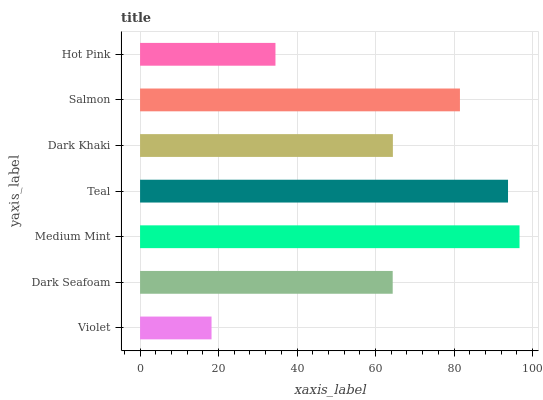Is Violet the minimum?
Answer yes or no. Yes. Is Medium Mint the maximum?
Answer yes or no. Yes. Is Dark Seafoam the minimum?
Answer yes or no. No. Is Dark Seafoam the maximum?
Answer yes or no. No. Is Dark Seafoam greater than Violet?
Answer yes or no. Yes. Is Violet less than Dark Seafoam?
Answer yes or no. Yes. Is Violet greater than Dark Seafoam?
Answer yes or no. No. Is Dark Seafoam less than Violet?
Answer yes or no. No. Is Dark Khaki the high median?
Answer yes or no. Yes. Is Dark Khaki the low median?
Answer yes or no. Yes. Is Teal the high median?
Answer yes or no. No. Is Hot Pink the low median?
Answer yes or no. No. 